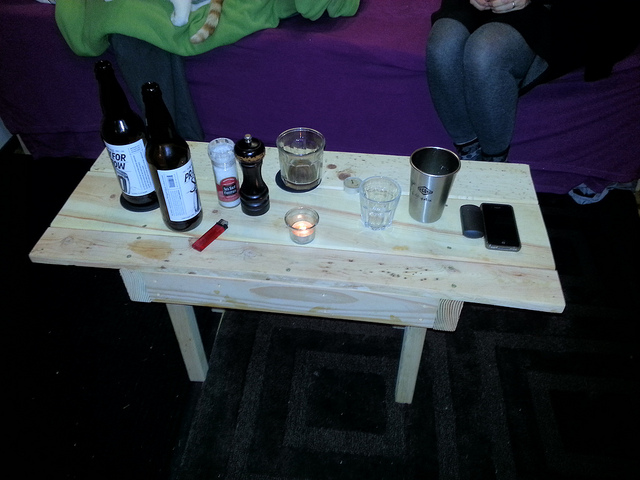How many bottles can you see? I can see three bottles positioned prominently on the table along with various other items. 